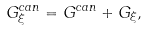Convert formula to latex. <formula><loc_0><loc_0><loc_500><loc_500>G _ { \xi } ^ { c a n } = G ^ { c a n } + G _ { \xi } ,</formula> 